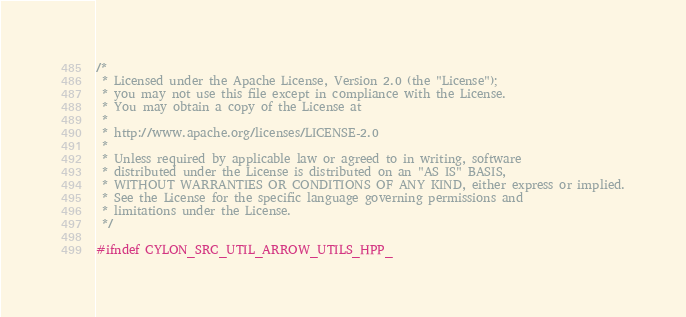<code> <loc_0><loc_0><loc_500><loc_500><_C++_>/*
 * Licensed under the Apache License, Version 2.0 (the "License");
 * you may not use this file except in compliance with the License.
 * You may obtain a copy of the License at
 *
 * http://www.apache.org/licenses/LICENSE-2.0
 *
 * Unless required by applicable law or agreed to in writing, software
 * distributed under the License is distributed on an "AS IS" BASIS,
 * WITHOUT WARRANTIES OR CONDITIONS OF ANY KIND, either express or implied.
 * See the License for the specific language governing permissions and
 * limitations under the License.
 */

#ifndef CYLON_SRC_UTIL_ARROW_UTILS_HPP_</code> 